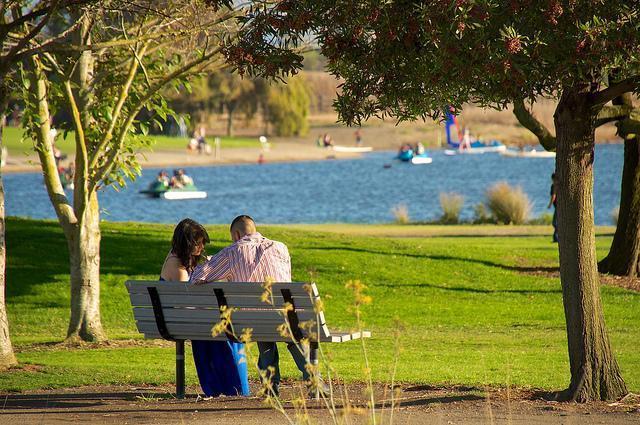How many boats are sailing?
Give a very brief answer. 4. How many people can be seen?
Give a very brief answer. 2. 